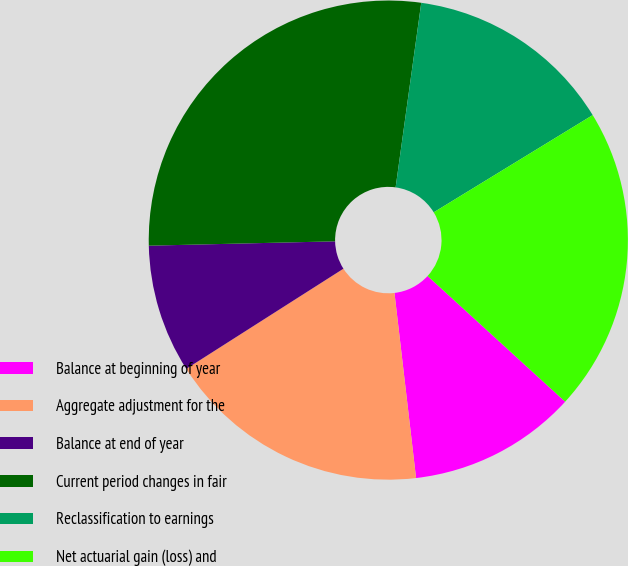Convert chart to OTSL. <chart><loc_0><loc_0><loc_500><loc_500><pie_chart><fcel>Balance at beginning of year<fcel>Aggregate adjustment for the<fcel>Balance at end of year<fcel>Current period changes in fair<fcel>Reclassification to earnings<fcel>Net actuarial gain (loss) and<nl><fcel>11.37%<fcel>17.82%<fcel>8.66%<fcel>27.57%<fcel>14.07%<fcel>20.52%<nl></chart> 